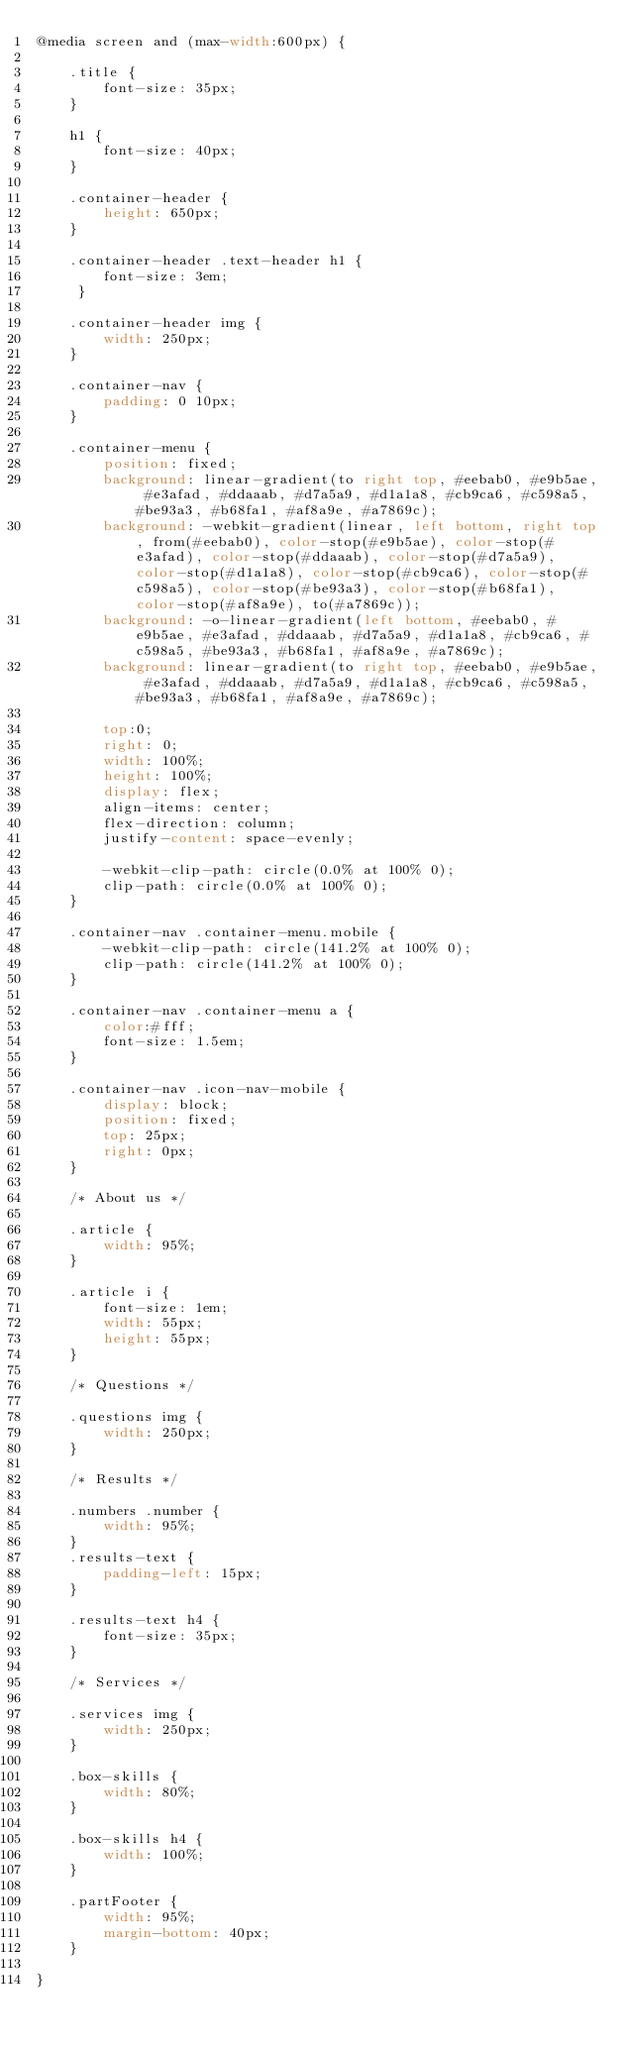<code> <loc_0><loc_0><loc_500><loc_500><_CSS_>@media screen and (max-width:600px) {

    .title {
        font-size: 35px;
    }

    h1 {
        font-size: 40px;
    }

    .container-header {
        height: 650px;
    }

    .container-header .text-header h1 {
        font-size: 3em;
     }

    .container-header img {
        width: 250px;
    }

    .container-nav {
        padding: 0 10px;
    }

    .container-menu {
        position: fixed;
        background: linear-gradient(to right top, #eebab0, #e9b5ae, #e3afad, #ddaaab, #d7a5a9, #d1a1a8, #cb9ca6, #c598a5, #be93a3, #b68fa1, #af8a9e, #a7869c);
        background: -webkit-gradient(linear, left bottom, right top, from(#eebab0), color-stop(#e9b5ae), color-stop(#e3afad), color-stop(#ddaaab), color-stop(#d7a5a9), color-stop(#d1a1a8), color-stop(#cb9ca6), color-stop(#c598a5), color-stop(#be93a3), color-stop(#b68fa1), color-stop(#af8a9e), to(#a7869c));
        background: -o-linear-gradient(left bottom, #eebab0, #e9b5ae, #e3afad, #ddaaab, #d7a5a9, #d1a1a8, #cb9ca6, #c598a5, #be93a3, #b68fa1, #af8a9e, #a7869c);
        background: linear-gradient(to right top, #eebab0, #e9b5ae, #e3afad, #ddaaab, #d7a5a9, #d1a1a8, #cb9ca6, #c598a5, #be93a3, #b68fa1, #af8a9e, #a7869c);

        top:0;
        right: 0;
        width: 100%;
        height: 100%;
        display: flex;
        align-items: center;
        flex-direction: column;
        justify-content: space-evenly;

        -webkit-clip-path: circle(0.0% at 100% 0);
        clip-path: circle(0.0% at 100% 0);
    }

    .container-nav .container-menu.mobile {
        -webkit-clip-path: circle(141.2% at 100% 0);
        clip-path: circle(141.2% at 100% 0);
    }

    .container-nav .container-menu a {
        color:#fff;
        font-size: 1.5em;
    }

    .container-nav .icon-nav-mobile {
        display: block;
        position: fixed;
        top: 25px;
        right: 0px;
    }

    /* About us */

    .article {
        width: 95%;
    }

    .article i {
        font-size: 1em;
        width: 55px;
        height: 55px;
    }

    /* Questions */

    .questions img {
        width: 250px;
    }

    /* Results */

    .numbers .number {
        width: 95%;
    }
    .results-text {
        padding-left: 15px;
    }

    .results-text h4 {
        font-size: 35px;
    }

    /* Services */

    .services img {
        width: 250px;
    }

    .box-skills {
        width: 80%;
    }

    .box-skills h4 {
        width: 100%;
    }

    .partFooter {
        width: 95%;
        margin-bottom: 40px;
    }

}</code> 